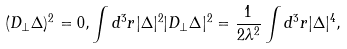<formula> <loc_0><loc_0><loc_500><loc_500>( { D } _ { \perp } \Delta ) ^ { 2 } = 0 , \int d ^ { 3 } r | \Delta | ^ { 2 } | { D } _ { \perp } \Delta | ^ { 2 } = \frac { 1 } { 2 \lambda ^ { 2 } } \int d ^ { 3 } r | \Delta | ^ { 4 } ,</formula> 